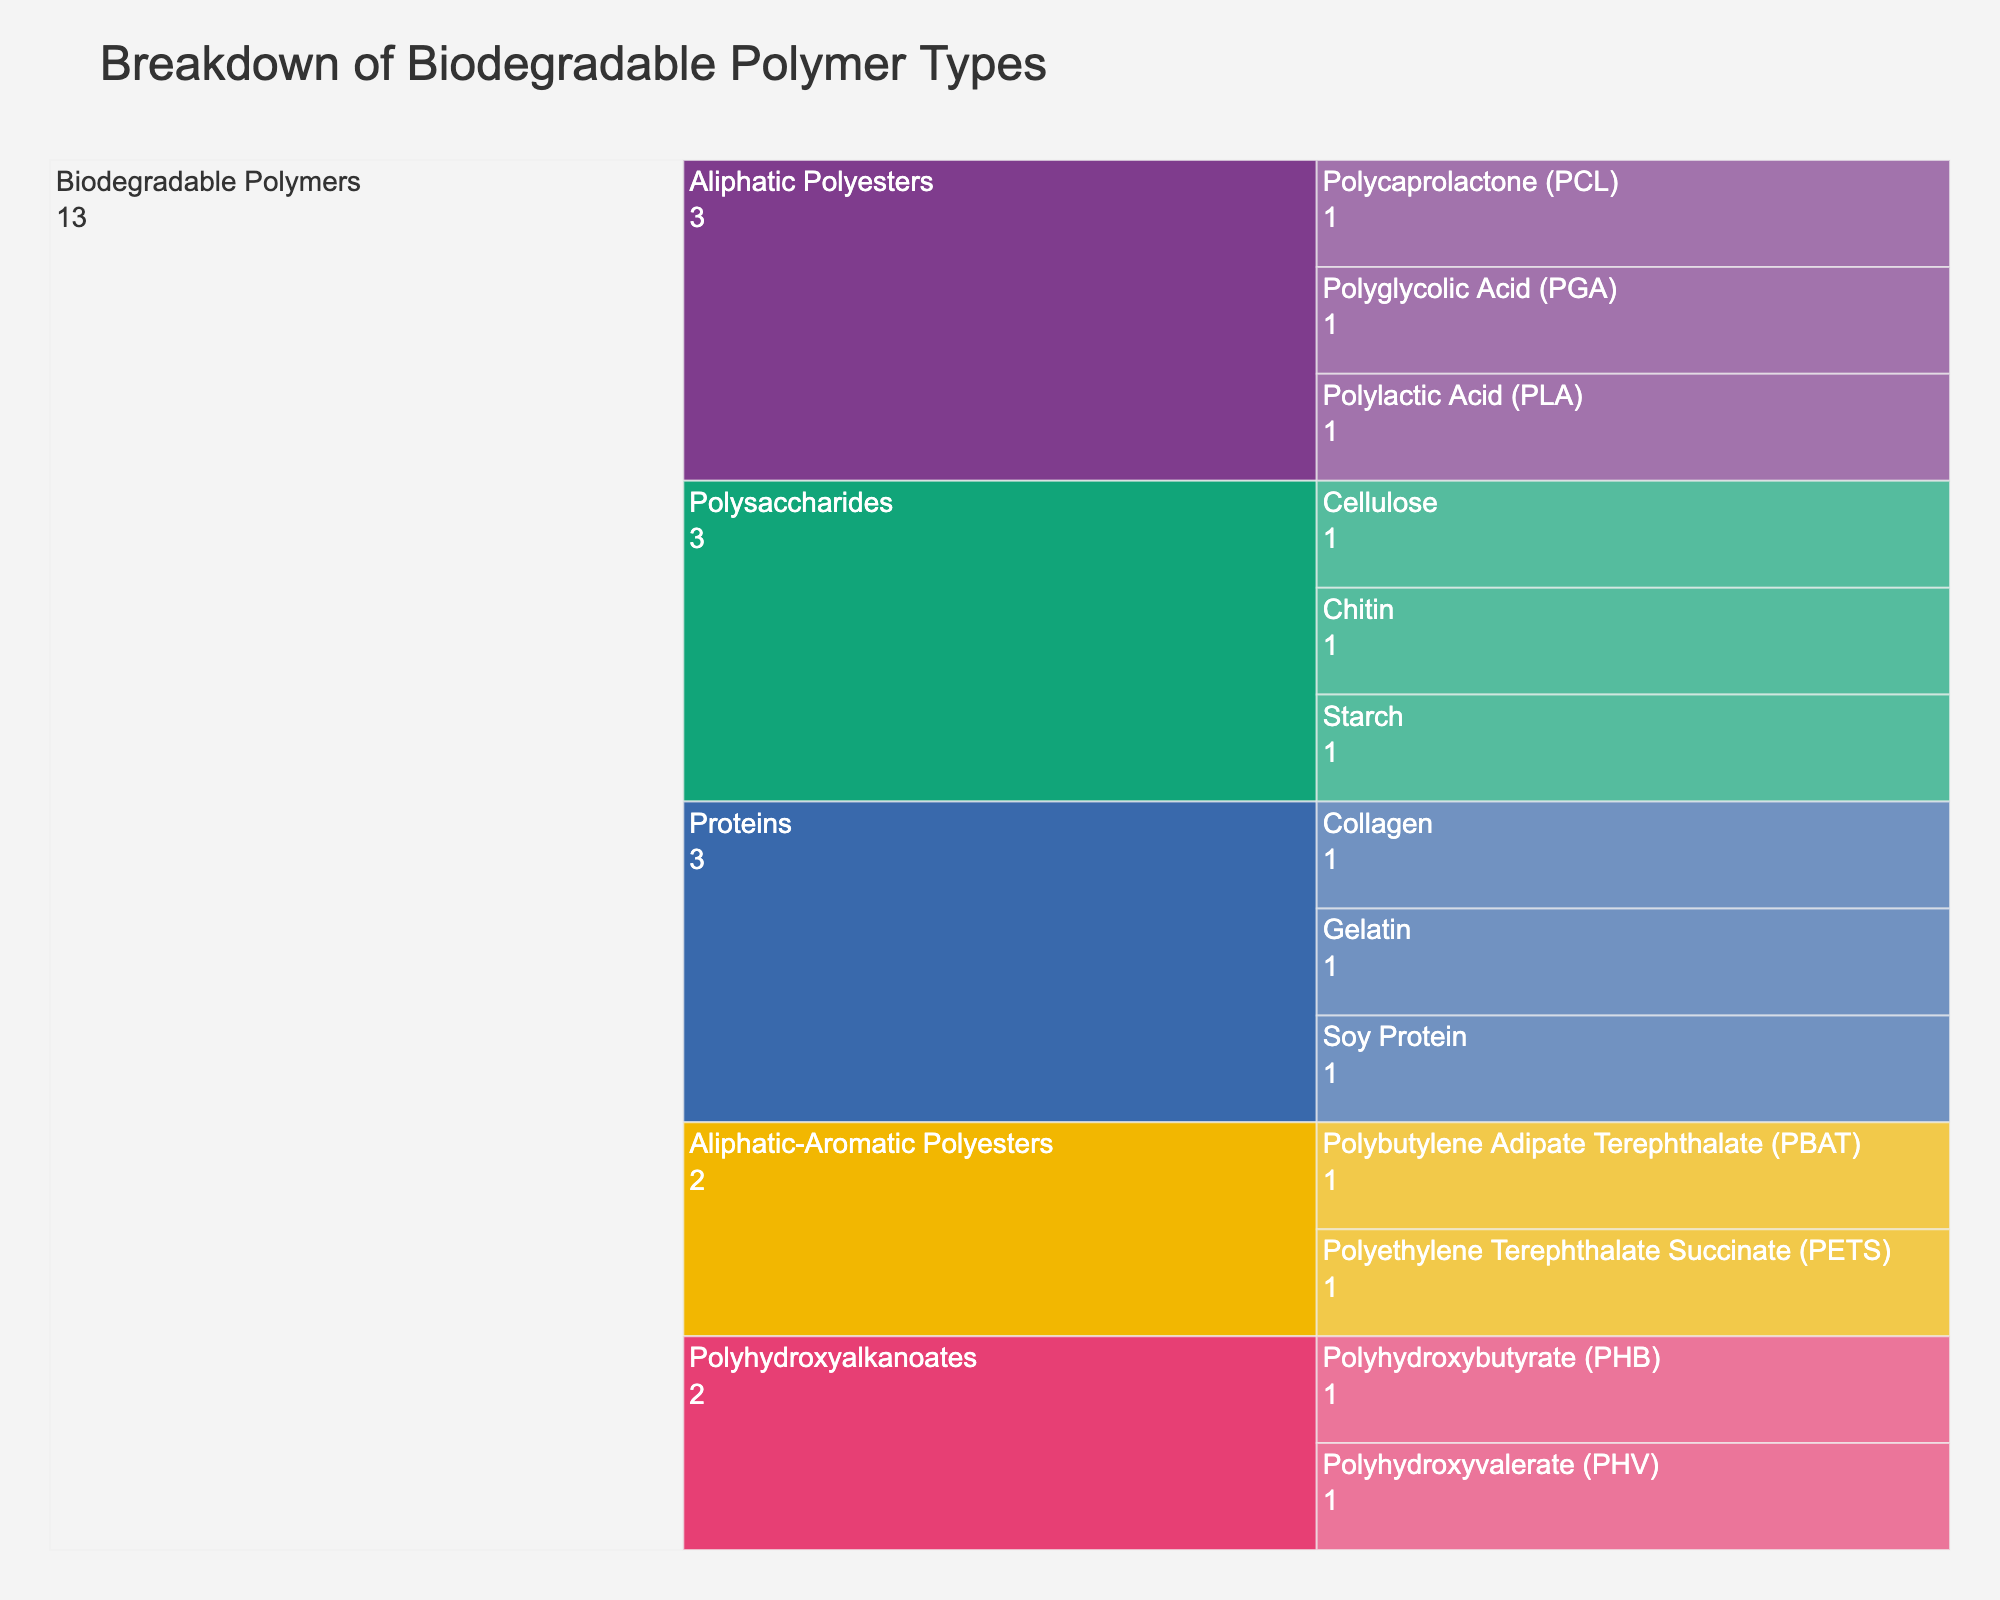what is the title of the chart? The title of the chart is visibly placed at the top of the figure and typically summarizes the purpose or content of the figure. In this case, it indicates that the chart categorizes different types of biodegradable polymers.
Answer: Breakdown of Biodegradable Polymer Types How many primary categories of biodegradable polymers are there? By examining the first level of the icicle chart, we can see the primary categories which give a high-level view of different types of polymers. Here, we only have one primary category labeled.
Answer: 1 How many types of biodegradable polymers are represented? By looking at the second level in the chart, we see various sections branching out from the primary category, each representing different types. Counting these sections will give us the number of types.
Answer: 5 Which type of biodegradable polymer includes both Polylactic Acid (PLA) and Polyglycolic Acid (PGA)? By following the branches in the chart, we can see where PLA and PGA are categorized. They fall under the subcategory of Aliphatic Polyesters.
Answer: Aliphatic Polyesters List all subclasses of Aliphatic Polyesters in the chart. Under the Aliphatic Polyesters type, there are multiple subclasses. By following the branches from Aliphatic Polyesters, we can list out each subclass.
Answer: Polylactic Acid (PLA), Polyglycolic Acid (PGA), Polycaprolactone (PCL) What is the difference in the number of subclasses between Polysaccharides and Polyhydroxyalkanoates? By looking at the third level under Polysaccharides and Polyhydroxyalkanoates, we count the number of subclasses in each category. Polysaccharides have 3 subclasses (Starch, Cellulose, Chitin), while Polyhydroxyalkanoates have 2 (Polyhydroxybutyrate (PHB), Polyhydroxyvalerate (PHV)). The difference is calculated as 3 - 2.
Answer: 1 Which type contains Collagen, Gelatin, and Soy Protein? By tracking the branches in the chart from these specific subclasses, we can identify that they all fall under the type labeled Proteins.
Answer: Proteins If a new subclass is added to "Aliphatic-Aromatic Polyesters", how many total subclasses would that type have? Currently, the Aliphatic-Aromatic Polyesters type has 2 subclasses (Polybutylene Adipate Terephthalate (PBAT) and Polyethylene Terephthalate Succinate (PETS)). Adding one more makes the total 3.
Answer: 3 What category does Chitin belong to? By following the branches in the chart, Chitin falls under the broader category labeled Polysaccharides.
Answer: Polysaccharides Which type of biodegradable polymer has the least number of subclasses? From an overview of the branches, we can compare the number of subclasses under each type. Polysaccharides have 3, Aliphatic Polyesters have 3, Aliphatic-Aromatic Polyesters have 2, Polyhydroxyalkanoates have 2, and Proteins have 3. Thus, the types with the least number of subclasses are Aliphatic-Aromatic Polyesters and Polyhydroxyalkanoates, each with 2 subclasses.
Answer: Aliphatic-Aromatic Polyesters, Polyhydroxyalkanoates 